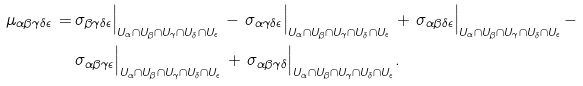Convert formula to latex. <formula><loc_0><loc_0><loc_500><loc_500>\mu _ { \alpha \beta \gamma \delta \epsilon } \, = \, & \sigma _ { \beta \gamma \delta \epsilon } \Big | _ { U _ { \alpha } \cap U _ { \beta } \cap U _ { \gamma } \cap U _ { \delta } \cap U _ { \epsilon } } \, - \, \sigma _ { \alpha \gamma \delta \epsilon } \Big | _ { U _ { \alpha } \cap U _ { \beta } \cap U _ { \gamma } \cap U _ { \delta } \cap U _ { \epsilon } } \, + \, \sigma _ { \alpha \beta \delta \epsilon } \Big | _ { U _ { \alpha } \cap U _ { \beta } \cap U _ { \gamma } \cap U _ { \delta } \cap U _ { \epsilon } } \, - \\ & \sigma _ { \alpha \beta \gamma \epsilon } \Big | _ { U _ { \alpha } \cap U _ { \beta } \cap U _ { \gamma } \cap U _ { \delta } \cap U _ { \epsilon } } \, + \, \sigma _ { \alpha \beta \gamma \delta } \Big | _ { U _ { \alpha } \cap U _ { \beta } \cap U _ { \gamma } \cap U _ { \delta } \cap U _ { \epsilon } } .</formula> 